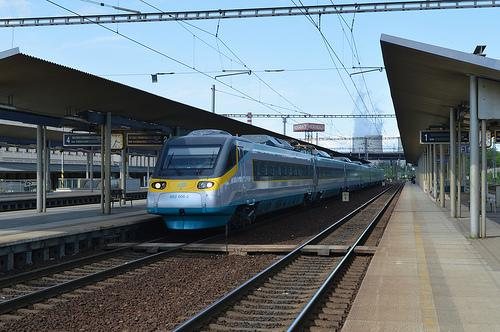Describe in detail an interesting item notable in the background of the photograph. In the background, there is a red and white striped structure, possibly a safety barrier or warning sign, measuring 10 pixels in width and height. For the multi-choice VQA task, which object is located closest to the top left corner of the image? c) Sign with the number 4 on it In a product advertisement, how would you market this train arriving at the station? Experience the ultimate in comfort and convenience with our modern, sleek yellow and white passenger train, as it swiftly glides into the station and transports you to your destination in style. Identify the primary color and type of train in the image. The primary color of the train is yellow and white, and it is a passenger train. For the referential expression grounding task, locate and describe the object near the bottom left corner of the image. At the bottom left corner of the image, there are rocks positioned between the railway tracks, with a width of 90 pixels and a height of 90 pixels. What type of sign is featured thrice with different numbers in the image? There are three numbered signs, each with a different digit - 1, 2, and 4. What do the numbers on the signs indicate about the train station? The numbers on the signs represent different platform numbers at the train station, namely platforms 1, 2, and 4. 